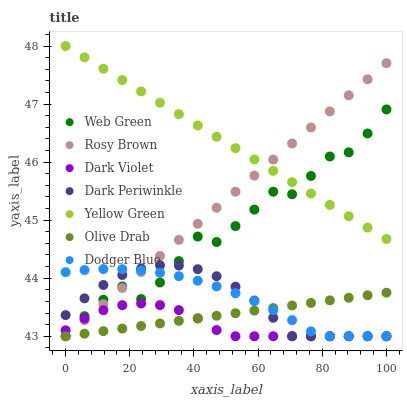Does Dark Violet have the minimum area under the curve?
Answer yes or no. Yes. Does Yellow Green have the maximum area under the curve?
Answer yes or no. Yes. Does Rosy Brown have the minimum area under the curve?
Answer yes or no. No. Does Rosy Brown have the maximum area under the curve?
Answer yes or no. No. Is Olive Drab the smoothest?
Answer yes or no. Yes. Is Web Green the roughest?
Answer yes or no. Yes. Is Rosy Brown the smoothest?
Answer yes or no. No. Is Rosy Brown the roughest?
Answer yes or no. No. Does Rosy Brown have the lowest value?
Answer yes or no. Yes. Does Yellow Green have the highest value?
Answer yes or no. Yes. Does Rosy Brown have the highest value?
Answer yes or no. No. Is Dark Violet less than Yellow Green?
Answer yes or no. Yes. Is Yellow Green greater than Dark Violet?
Answer yes or no. Yes. Does Dodger Blue intersect Rosy Brown?
Answer yes or no. Yes. Is Dodger Blue less than Rosy Brown?
Answer yes or no. No. Is Dodger Blue greater than Rosy Brown?
Answer yes or no. No. Does Dark Violet intersect Yellow Green?
Answer yes or no. No. 